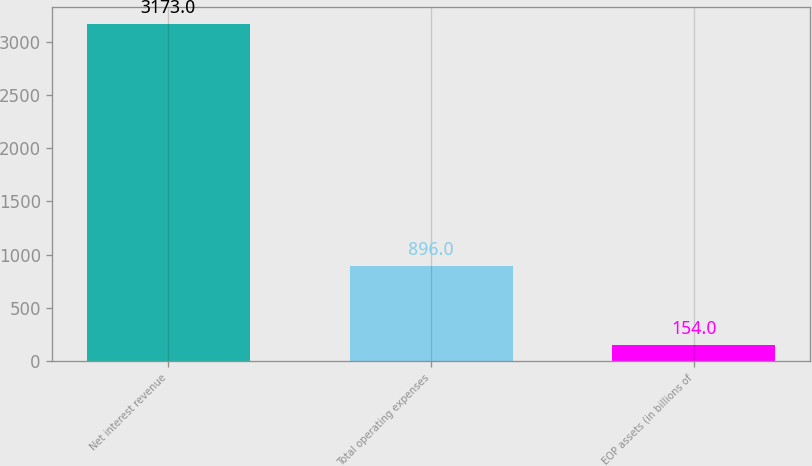Convert chart. <chart><loc_0><loc_0><loc_500><loc_500><bar_chart><fcel>Net interest revenue<fcel>Total operating expenses<fcel>EOP assets (in billions of<nl><fcel>3173<fcel>896<fcel>154<nl></chart> 